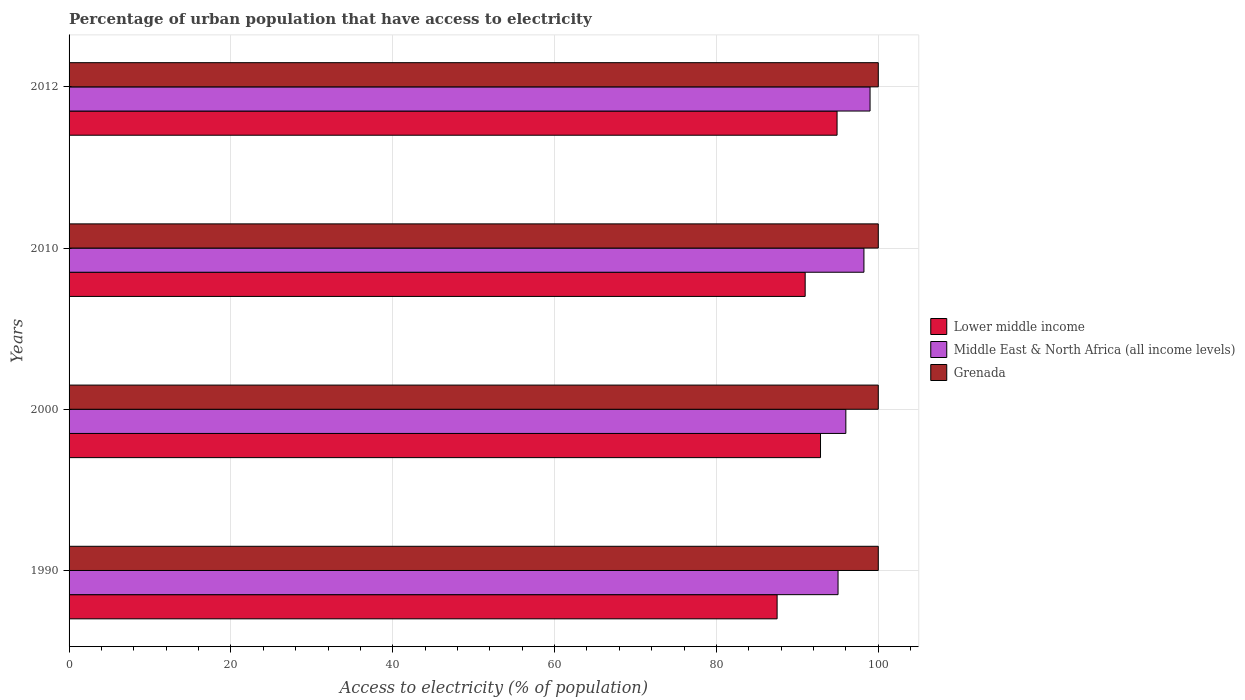How many bars are there on the 3rd tick from the top?
Offer a very short reply. 3. What is the label of the 4th group of bars from the top?
Keep it short and to the point. 1990. In how many cases, is the number of bars for a given year not equal to the number of legend labels?
Your answer should be very brief. 0. What is the percentage of urban population that have access to electricity in Lower middle income in 2000?
Your response must be concise. 92.86. Across all years, what is the maximum percentage of urban population that have access to electricity in Middle East & North Africa (all income levels)?
Offer a very short reply. 98.98. Across all years, what is the minimum percentage of urban population that have access to electricity in Lower middle income?
Keep it short and to the point. 87.5. In which year was the percentage of urban population that have access to electricity in Middle East & North Africa (all income levels) maximum?
Keep it short and to the point. 2012. In which year was the percentage of urban population that have access to electricity in Middle East & North Africa (all income levels) minimum?
Offer a very short reply. 1990. What is the total percentage of urban population that have access to electricity in Grenada in the graph?
Your response must be concise. 400. What is the difference between the percentage of urban population that have access to electricity in Lower middle income in 2000 and that in 2010?
Give a very brief answer. 1.9. What is the difference between the percentage of urban population that have access to electricity in Middle East & North Africa (all income levels) in 1990 and the percentage of urban population that have access to electricity in Grenada in 2000?
Give a very brief answer. -4.97. What is the average percentage of urban population that have access to electricity in Middle East & North Africa (all income levels) per year?
Offer a terse response. 97.06. In the year 2010, what is the difference between the percentage of urban population that have access to electricity in Grenada and percentage of urban population that have access to electricity in Lower middle income?
Offer a terse response. 9.03. What is the ratio of the percentage of urban population that have access to electricity in Middle East & North Africa (all income levels) in 1990 to that in 2010?
Your answer should be very brief. 0.97. Is the percentage of urban population that have access to electricity in Middle East & North Africa (all income levels) in 1990 less than that in 2012?
Provide a short and direct response. Yes. What is the difference between the highest and the second highest percentage of urban population that have access to electricity in Grenada?
Ensure brevity in your answer.  0. What is the difference between the highest and the lowest percentage of urban population that have access to electricity in Lower middle income?
Your answer should be very brief. 7.41. In how many years, is the percentage of urban population that have access to electricity in Middle East & North Africa (all income levels) greater than the average percentage of urban population that have access to electricity in Middle East & North Africa (all income levels) taken over all years?
Ensure brevity in your answer.  2. What does the 1st bar from the top in 2010 represents?
Give a very brief answer. Grenada. What does the 3rd bar from the bottom in 1990 represents?
Make the answer very short. Grenada. Is it the case that in every year, the sum of the percentage of urban population that have access to electricity in Middle East & North Africa (all income levels) and percentage of urban population that have access to electricity in Grenada is greater than the percentage of urban population that have access to electricity in Lower middle income?
Make the answer very short. Yes. How many bars are there?
Offer a terse response. 12. How many years are there in the graph?
Provide a succinct answer. 4. What is the difference between two consecutive major ticks on the X-axis?
Your answer should be compact. 20. Are the values on the major ticks of X-axis written in scientific E-notation?
Ensure brevity in your answer.  No. Does the graph contain grids?
Ensure brevity in your answer.  Yes. Where does the legend appear in the graph?
Provide a succinct answer. Center right. How many legend labels are there?
Provide a succinct answer. 3. What is the title of the graph?
Make the answer very short. Percentage of urban population that have access to electricity. Does "Papua New Guinea" appear as one of the legend labels in the graph?
Keep it short and to the point. No. What is the label or title of the X-axis?
Provide a succinct answer. Access to electricity (% of population). What is the Access to electricity (% of population) in Lower middle income in 1990?
Keep it short and to the point. 87.5. What is the Access to electricity (% of population) in Middle East & North Africa (all income levels) in 1990?
Your answer should be compact. 95.03. What is the Access to electricity (% of population) of Lower middle income in 2000?
Ensure brevity in your answer.  92.86. What is the Access to electricity (% of population) of Middle East & North Africa (all income levels) in 2000?
Keep it short and to the point. 95.99. What is the Access to electricity (% of population) of Lower middle income in 2010?
Your answer should be compact. 90.97. What is the Access to electricity (% of population) of Middle East & North Africa (all income levels) in 2010?
Your answer should be compact. 98.23. What is the Access to electricity (% of population) of Lower middle income in 2012?
Offer a terse response. 94.91. What is the Access to electricity (% of population) in Middle East & North Africa (all income levels) in 2012?
Your answer should be compact. 98.98. Across all years, what is the maximum Access to electricity (% of population) of Lower middle income?
Offer a very short reply. 94.91. Across all years, what is the maximum Access to electricity (% of population) of Middle East & North Africa (all income levels)?
Ensure brevity in your answer.  98.98. Across all years, what is the minimum Access to electricity (% of population) in Lower middle income?
Provide a succinct answer. 87.5. Across all years, what is the minimum Access to electricity (% of population) of Middle East & North Africa (all income levels)?
Make the answer very short. 95.03. Across all years, what is the minimum Access to electricity (% of population) of Grenada?
Offer a terse response. 100. What is the total Access to electricity (% of population) of Lower middle income in the graph?
Your answer should be very brief. 366.23. What is the total Access to electricity (% of population) in Middle East & North Africa (all income levels) in the graph?
Give a very brief answer. 388.23. What is the total Access to electricity (% of population) of Grenada in the graph?
Ensure brevity in your answer.  400. What is the difference between the Access to electricity (% of population) of Lower middle income in 1990 and that in 2000?
Provide a short and direct response. -5.36. What is the difference between the Access to electricity (% of population) of Middle East & North Africa (all income levels) in 1990 and that in 2000?
Provide a short and direct response. -0.96. What is the difference between the Access to electricity (% of population) of Grenada in 1990 and that in 2000?
Keep it short and to the point. 0. What is the difference between the Access to electricity (% of population) in Lower middle income in 1990 and that in 2010?
Your response must be concise. -3.47. What is the difference between the Access to electricity (% of population) in Middle East & North Africa (all income levels) in 1990 and that in 2010?
Your response must be concise. -3.2. What is the difference between the Access to electricity (% of population) of Lower middle income in 1990 and that in 2012?
Your answer should be compact. -7.41. What is the difference between the Access to electricity (% of population) of Middle East & North Africa (all income levels) in 1990 and that in 2012?
Provide a succinct answer. -3.96. What is the difference between the Access to electricity (% of population) of Grenada in 1990 and that in 2012?
Make the answer very short. 0. What is the difference between the Access to electricity (% of population) in Lower middle income in 2000 and that in 2010?
Offer a terse response. 1.9. What is the difference between the Access to electricity (% of population) in Middle East & North Africa (all income levels) in 2000 and that in 2010?
Keep it short and to the point. -2.24. What is the difference between the Access to electricity (% of population) of Grenada in 2000 and that in 2010?
Give a very brief answer. 0. What is the difference between the Access to electricity (% of population) in Lower middle income in 2000 and that in 2012?
Provide a succinct answer. -2.05. What is the difference between the Access to electricity (% of population) in Middle East & North Africa (all income levels) in 2000 and that in 2012?
Provide a short and direct response. -2.99. What is the difference between the Access to electricity (% of population) in Grenada in 2000 and that in 2012?
Ensure brevity in your answer.  0. What is the difference between the Access to electricity (% of population) in Lower middle income in 2010 and that in 2012?
Your answer should be very brief. -3.94. What is the difference between the Access to electricity (% of population) of Middle East & North Africa (all income levels) in 2010 and that in 2012?
Make the answer very short. -0.76. What is the difference between the Access to electricity (% of population) in Lower middle income in 1990 and the Access to electricity (% of population) in Middle East & North Africa (all income levels) in 2000?
Keep it short and to the point. -8.49. What is the difference between the Access to electricity (% of population) of Lower middle income in 1990 and the Access to electricity (% of population) of Grenada in 2000?
Make the answer very short. -12.5. What is the difference between the Access to electricity (% of population) of Middle East & North Africa (all income levels) in 1990 and the Access to electricity (% of population) of Grenada in 2000?
Keep it short and to the point. -4.97. What is the difference between the Access to electricity (% of population) of Lower middle income in 1990 and the Access to electricity (% of population) of Middle East & North Africa (all income levels) in 2010?
Provide a succinct answer. -10.73. What is the difference between the Access to electricity (% of population) of Lower middle income in 1990 and the Access to electricity (% of population) of Grenada in 2010?
Your answer should be very brief. -12.5. What is the difference between the Access to electricity (% of population) in Middle East & North Africa (all income levels) in 1990 and the Access to electricity (% of population) in Grenada in 2010?
Make the answer very short. -4.97. What is the difference between the Access to electricity (% of population) of Lower middle income in 1990 and the Access to electricity (% of population) of Middle East & North Africa (all income levels) in 2012?
Your answer should be very brief. -11.49. What is the difference between the Access to electricity (% of population) in Lower middle income in 1990 and the Access to electricity (% of population) in Grenada in 2012?
Ensure brevity in your answer.  -12.5. What is the difference between the Access to electricity (% of population) of Middle East & North Africa (all income levels) in 1990 and the Access to electricity (% of population) of Grenada in 2012?
Make the answer very short. -4.97. What is the difference between the Access to electricity (% of population) of Lower middle income in 2000 and the Access to electricity (% of population) of Middle East & North Africa (all income levels) in 2010?
Offer a terse response. -5.37. What is the difference between the Access to electricity (% of population) of Lower middle income in 2000 and the Access to electricity (% of population) of Grenada in 2010?
Your response must be concise. -7.14. What is the difference between the Access to electricity (% of population) of Middle East & North Africa (all income levels) in 2000 and the Access to electricity (% of population) of Grenada in 2010?
Provide a succinct answer. -4.01. What is the difference between the Access to electricity (% of population) of Lower middle income in 2000 and the Access to electricity (% of population) of Middle East & North Africa (all income levels) in 2012?
Make the answer very short. -6.12. What is the difference between the Access to electricity (% of population) of Lower middle income in 2000 and the Access to electricity (% of population) of Grenada in 2012?
Provide a succinct answer. -7.14. What is the difference between the Access to electricity (% of population) of Middle East & North Africa (all income levels) in 2000 and the Access to electricity (% of population) of Grenada in 2012?
Give a very brief answer. -4.01. What is the difference between the Access to electricity (% of population) in Lower middle income in 2010 and the Access to electricity (% of population) in Middle East & North Africa (all income levels) in 2012?
Your answer should be compact. -8.02. What is the difference between the Access to electricity (% of population) of Lower middle income in 2010 and the Access to electricity (% of population) of Grenada in 2012?
Provide a succinct answer. -9.03. What is the difference between the Access to electricity (% of population) in Middle East & North Africa (all income levels) in 2010 and the Access to electricity (% of population) in Grenada in 2012?
Provide a succinct answer. -1.77. What is the average Access to electricity (% of population) in Lower middle income per year?
Ensure brevity in your answer.  91.56. What is the average Access to electricity (% of population) in Middle East & North Africa (all income levels) per year?
Make the answer very short. 97.06. What is the average Access to electricity (% of population) of Grenada per year?
Keep it short and to the point. 100. In the year 1990, what is the difference between the Access to electricity (% of population) of Lower middle income and Access to electricity (% of population) of Middle East & North Africa (all income levels)?
Ensure brevity in your answer.  -7.53. In the year 1990, what is the difference between the Access to electricity (% of population) of Lower middle income and Access to electricity (% of population) of Grenada?
Your answer should be very brief. -12.5. In the year 1990, what is the difference between the Access to electricity (% of population) in Middle East & North Africa (all income levels) and Access to electricity (% of population) in Grenada?
Ensure brevity in your answer.  -4.97. In the year 2000, what is the difference between the Access to electricity (% of population) in Lower middle income and Access to electricity (% of population) in Middle East & North Africa (all income levels)?
Keep it short and to the point. -3.13. In the year 2000, what is the difference between the Access to electricity (% of population) in Lower middle income and Access to electricity (% of population) in Grenada?
Ensure brevity in your answer.  -7.14. In the year 2000, what is the difference between the Access to electricity (% of population) of Middle East & North Africa (all income levels) and Access to electricity (% of population) of Grenada?
Offer a terse response. -4.01. In the year 2010, what is the difference between the Access to electricity (% of population) of Lower middle income and Access to electricity (% of population) of Middle East & North Africa (all income levels)?
Give a very brief answer. -7.26. In the year 2010, what is the difference between the Access to electricity (% of population) in Lower middle income and Access to electricity (% of population) in Grenada?
Ensure brevity in your answer.  -9.03. In the year 2010, what is the difference between the Access to electricity (% of population) in Middle East & North Africa (all income levels) and Access to electricity (% of population) in Grenada?
Keep it short and to the point. -1.77. In the year 2012, what is the difference between the Access to electricity (% of population) in Lower middle income and Access to electricity (% of population) in Middle East & North Africa (all income levels)?
Provide a succinct answer. -4.08. In the year 2012, what is the difference between the Access to electricity (% of population) of Lower middle income and Access to electricity (% of population) of Grenada?
Give a very brief answer. -5.09. In the year 2012, what is the difference between the Access to electricity (% of population) of Middle East & North Africa (all income levels) and Access to electricity (% of population) of Grenada?
Provide a succinct answer. -1.02. What is the ratio of the Access to electricity (% of population) of Lower middle income in 1990 to that in 2000?
Your response must be concise. 0.94. What is the ratio of the Access to electricity (% of population) in Lower middle income in 1990 to that in 2010?
Your response must be concise. 0.96. What is the ratio of the Access to electricity (% of population) of Middle East & North Africa (all income levels) in 1990 to that in 2010?
Provide a succinct answer. 0.97. What is the ratio of the Access to electricity (% of population) in Lower middle income in 1990 to that in 2012?
Provide a succinct answer. 0.92. What is the ratio of the Access to electricity (% of population) of Lower middle income in 2000 to that in 2010?
Ensure brevity in your answer.  1.02. What is the ratio of the Access to electricity (% of population) in Middle East & North Africa (all income levels) in 2000 to that in 2010?
Give a very brief answer. 0.98. What is the ratio of the Access to electricity (% of population) of Grenada in 2000 to that in 2010?
Ensure brevity in your answer.  1. What is the ratio of the Access to electricity (% of population) in Lower middle income in 2000 to that in 2012?
Offer a very short reply. 0.98. What is the ratio of the Access to electricity (% of population) in Middle East & North Africa (all income levels) in 2000 to that in 2012?
Provide a short and direct response. 0.97. What is the ratio of the Access to electricity (% of population) of Lower middle income in 2010 to that in 2012?
Offer a terse response. 0.96. What is the ratio of the Access to electricity (% of population) of Grenada in 2010 to that in 2012?
Ensure brevity in your answer.  1. What is the difference between the highest and the second highest Access to electricity (% of population) of Lower middle income?
Offer a very short reply. 2.05. What is the difference between the highest and the second highest Access to electricity (% of population) of Middle East & North Africa (all income levels)?
Give a very brief answer. 0.76. What is the difference between the highest and the second highest Access to electricity (% of population) of Grenada?
Provide a short and direct response. 0. What is the difference between the highest and the lowest Access to electricity (% of population) in Lower middle income?
Provide a short and direct response. 7.41. What is the difference between the highest and the lowest Access to electricity (% of population) of Middle East & North Africa (all income levels)?
Make the answer very short. 3.96. 